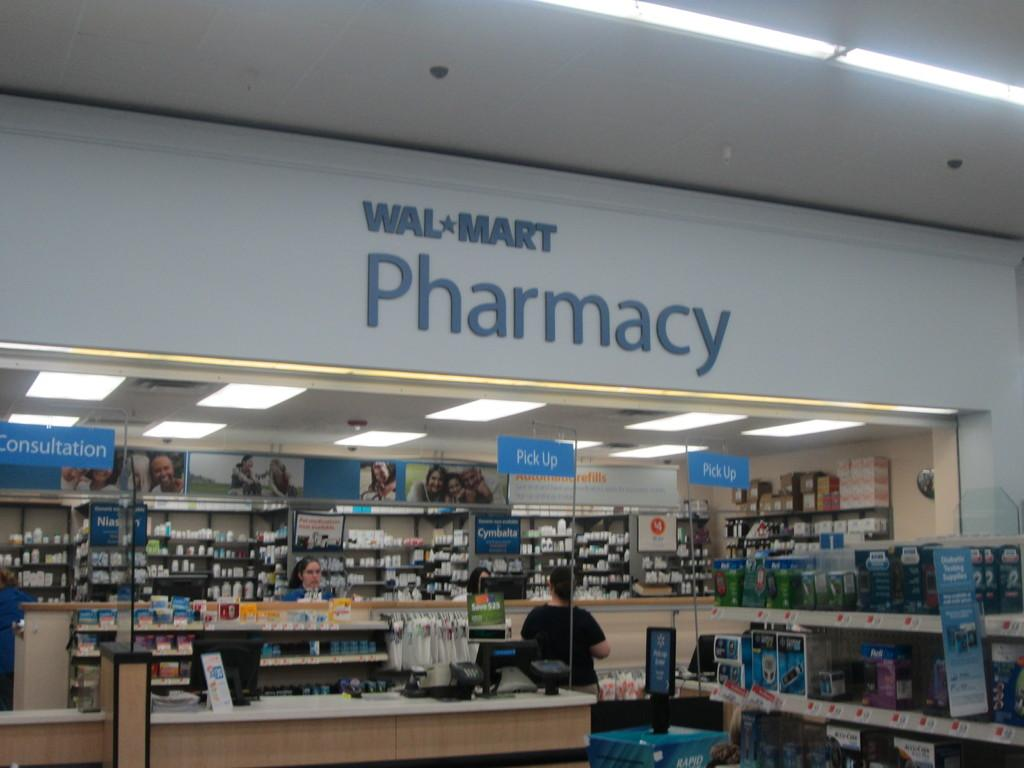<image>
Provide a brief description of the given image. Walmart Pharmacy with many shelves filled with all different items and a check out counter. 